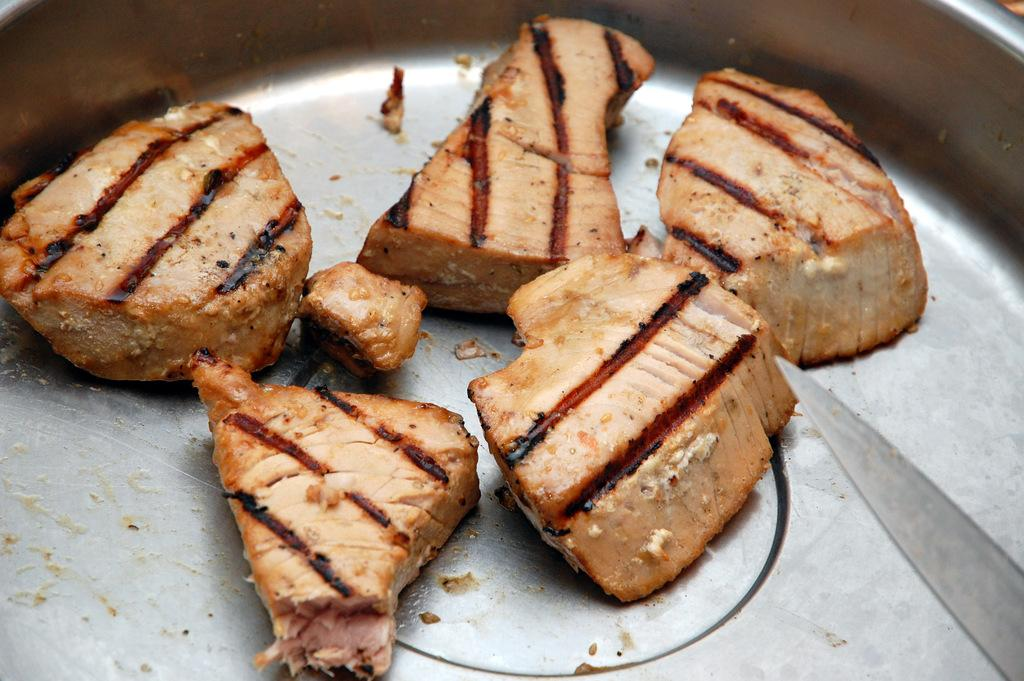What type of tray is in the image? There is a steel tray in the image. What is on the tray? The tray contains eatables. What utensil is present in the image? There is a knife in the image. Where is the baby playing with sand in the image? There is no baby or sand present in the image; it features a steel tray with eatables and a knife. 